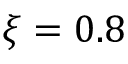<formula> <loc_0><loc_0><loc_500><loc_500>\xi = 0 . 8</formula> 